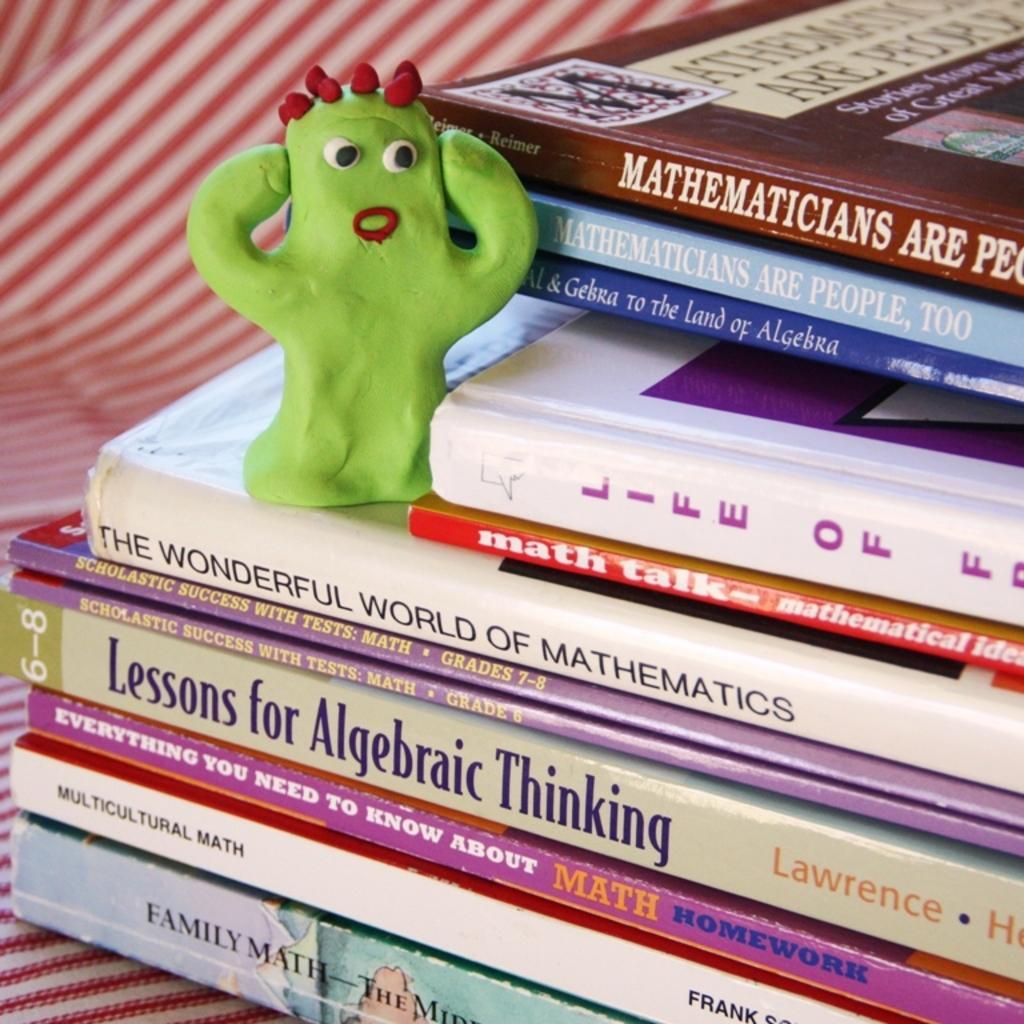Can you describe this image briefly? In the picture there is a collection of books and on one of the book there is a toy. 